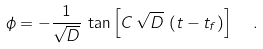<formula> <loc_0><loc_0><loc_500><loc_500>\phi = - \frac { 1 } { \sqrt { D } } \, \tan { \left [ C \, \sqrt { D } \, \left ( t - t _ { f } \right ) \right ] } \ \ .</formula> 